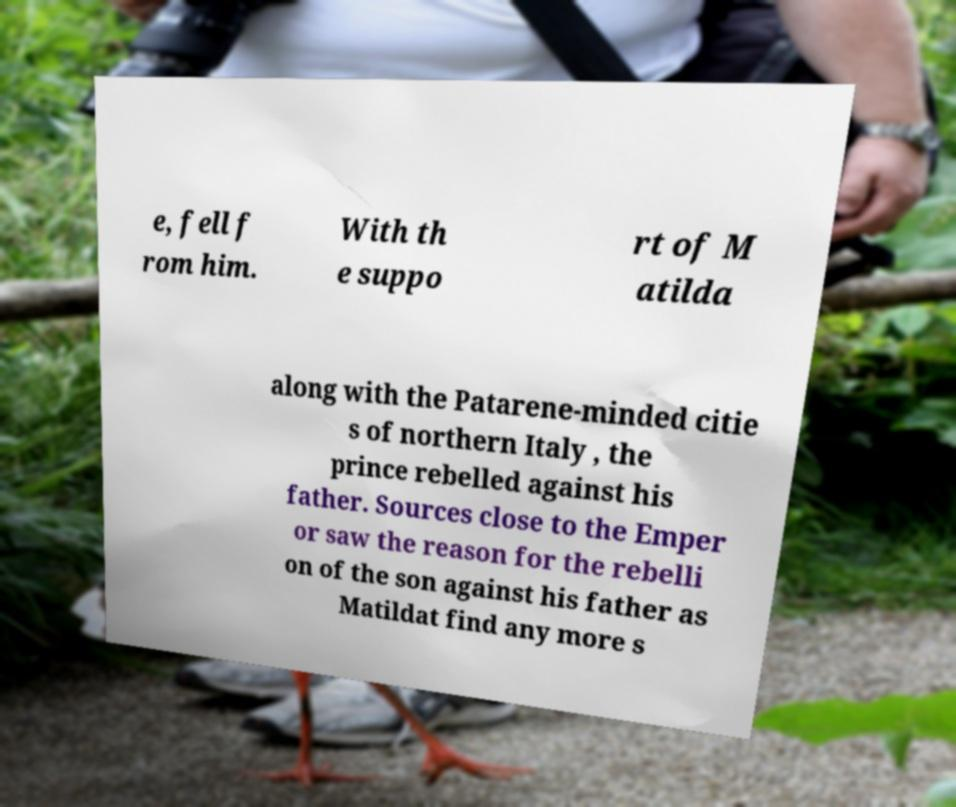Can you read and provide the text displayed in the image?This photo seems to have some interesting text. Can you extract and type it out for me? e, fell f rom him. With th e suppo rt of M atilda along with the Patarene-minded citie s of northern Italy , the prince rebelled against his father. Sources close to the Emper or saw the reason for the rebelli on of the son against his father as Matildat find any more s 